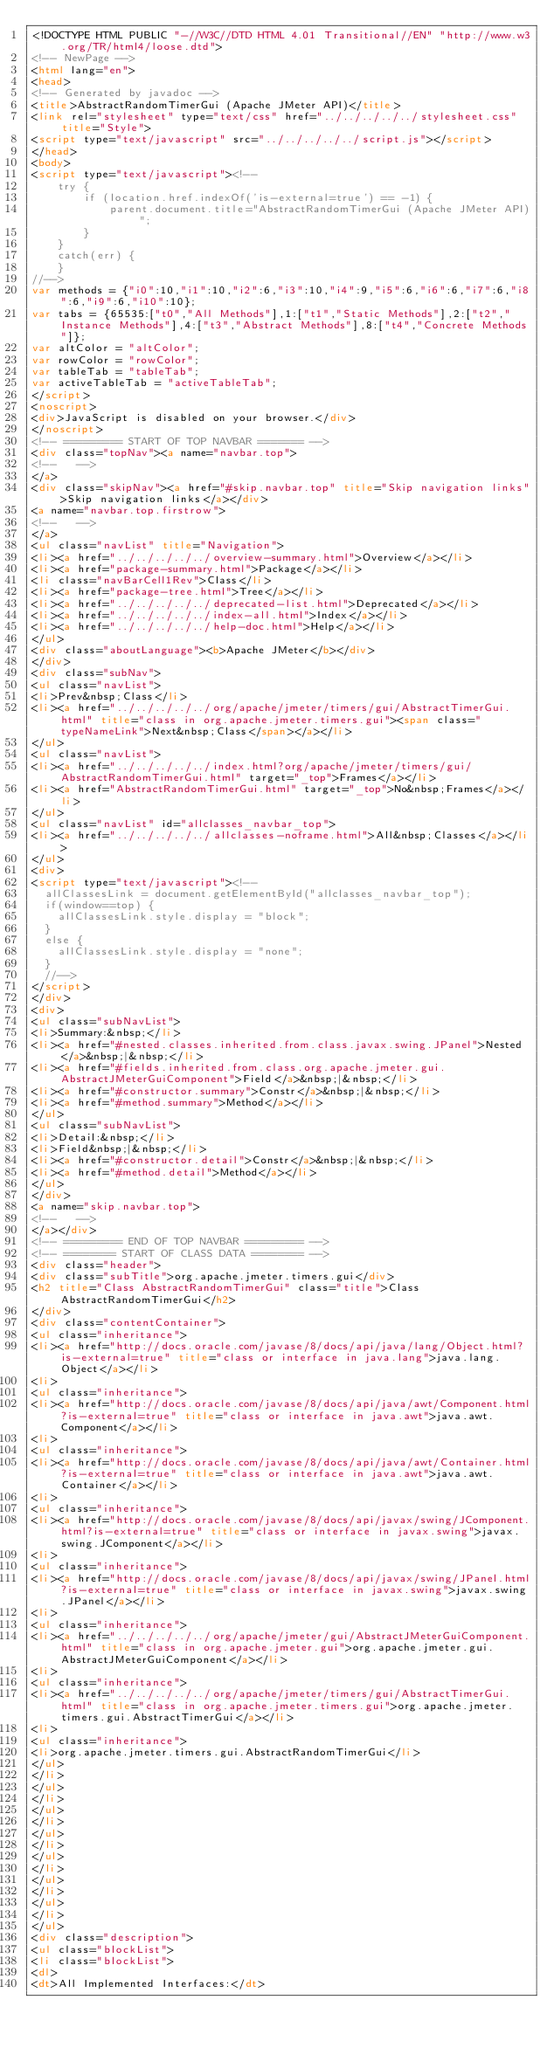<code> <loc_0><loc_0><loc_500><loc_500><_HTML_><!DOCTYPE HTML PUBLIC "-//W3C//DTD HTML 4.01 Transitional//EN" "http://www.w3.org/TR/html4/loose.dtd">
<!-- NewPage -->
<html lang="en">
<head>
<!-- Generated by javadoc -->
<title>AbstractRandomTimerGui (Apache JMeter API)</title>
<link rel="stylesheet" type="text/css" href="../../../../../stylesheet.css" title="Style">
<script type="text/javascript" src="../../../../../script.js"></script>
</head>
<body>
<script type="text/javascript"><!--
    try {
        if (location.href.indexOf('is-external=true') == -1) {
            parent.document.title="AbstractRandomTimerGui (Apache JMeter API)";
        }
    }
    catch(err) {
    }
//-->
var methods = {"i0":10,"i1":10,"i2":6,"i3":10,"i4":9,"i5":6,"i6":6,"i7":6,"i8":6,"i9":6,"i10":10};
var tabs = {65535:["t0","All Methods"],1:["t1","Static Methods"],2:["t2","Instance Methods"],4:["t3","Abstract Methods"],8:["t4","Concrete Methods"]};
var altColor = "altColor";
var rowColor = "rowColor";
var tableTab = "tableTab";
var activeTableTab = "activeTableTab";
</script>
<noscript>
<div>JavaScript is disabled on your browser.</div>
</noscript>
<!-- ========= START OF TOP NAVBAR ======= -->
<div class="topNav"><a name="navbar.top">
<!--   -->
</a>
<div class="skipNav"><a href="#skip.navbar.top" title="Skip navigation links">Skip navigation links</a></div>
<a name="navbar.top.firstrow">
<!--   -->
</a>
<ul class="navList" title="Navigation">
<li><a href="../../../../../overview-summary.html">Overview</a></li>
<li><a href="package-summary.html">Package</a></li>
<li class="navBarCell1Rev">Class</li>
<li><a href="package-tree.html">Tree</a></li>
<li><a href="../../../../../deprecated-list.html">Deprecated</a></li>
<li><a href="../../../../../index-all.html">Index</a></li>
<li><a href="../../../../../help-doc.html">Help</a></li>
</ul>
<div class="aboutLanguage"><b>Apache JMeter</b></div>
</div>
<div class="subNav">
<ul class="navList">
<li>Prev&nbsp;Class</li>
<li><a href="../../../../../org/apache/jmeter/timers/gui/AbstractTimerGui.html" title="class in org.apache.jmeter.timers.gui"><span class="typeNameLink">Next&nbsp;Class</span></a></li>
</ul>
<ul class="navList">
<li><a href="../../../../../index.html?org/apache/jmeter/timers/gui/AbstractRandomTimerGui.html" target="_top">Frames</a></li>
<li><a href="AbstractRandomTimerGui.html" target="_top">No&nbsp;Frames</a></li>
</ul>
<ul class="navList" id="allclasses_navbar_top">
<li><a href="../../../../../allclasses-noframe.html">All&nbsp;Classes</a></li>
</ul>
<div>
<script type="text/javascript"><!--
  allClassesLink = document.getElementById("allclasses_navbar_top");
  if(window==top) {
    allClassesLink.style.display = "block";
  }
  else {
    allClassesLink.style.display = "none";
  }
  //-->
</script>
</div>
<div>
<ul class="subNavList">
<li>Summary:&nbsp;</li>
<li><a href="#nested.classes.inherited.from.class.javax.swing.JPanel">Nested</a>&nbsp;|&nbsp;</li>
<li><a href="#fields.inherited.from.class.org.apache.jmeter.gui.AbstractJMeterGuiComponent">Field</a>&nbsp;|&nbsp;</li>
<li><a href="#constructor.summary">Constr</a>&nbsp;|&nbsp;</li>
<li><a href="#method.summary">Method</a></li>
</ul>
<ul class="subNavList">
<li>Detail:&nbsp;</li>
<li>Field&nbsp;|&nbsp;</li>
<li><a href="#constructor.detail">Constr</a>&nbsp;|&nbsp;</li>
<li><a href="#method.detail">Method</a></li>
</ul>
</div>
<a name="skip.navbar.top">
<!--   -->
</a></div>
<!-- ========= END OF TOP NAVBAR ========= -->
<!-- ======== START OF CLASS DATA ======== -->
<div class="header">
<div class="subTitle">org.apache.jmeter.timers.gui</div>
<h2 title="Class AbstractRandomTimerGui" class="title">Class AbstractRandomTimerGui</h2>
</div>
<div class="contentContainer">
<ul class="inheritance">
<li><a href="http://docs.oracle.com/javase/8/docs/api/java/lang/Object.html?is-external=true" title="class or interface in java.lang">java.lang.Object</a></li>
<li>
<ul class="inheritance">
<li><a href="http://docs.oracle.com/javase/8/docs/api/java/awt/Component.html?is-external=true" title="class or interface in java.awt">java.awt.Component</a></li>
<li>
<ul class="inheritance">
<li><a href="http://docs.oracle.com/javase/8/docs/api/java/awt/Container.html?is-external=true" title="class or interface in java.awt">java.awt.Container</a></li>
<li>
<ul class="inheritance">
<li><a href="http://docs.oracle.com/javase/8/docs/api/javax/swing/JComponent.html?is-external=true" title="class or interface in javax.swing">javax.swing.JComponent</a></li>
<li>
<ul class="inheritance">
<li><a href="http://docs.oracle.com/javase/8/docs/api/javax/swing/JPanel.html?is-external=true" title="class or interface in javax.swing">javax.swing.JPanel</a></li>
<li>
<ul class="inheritance">
<li><a href="../../../../../org/apache/jmeter/gui/AbstractJMeterGuiComponent.html" title="class in org.apache.jmeter.gui">org.apache.jmeter.gui.AbstractJMeterGuiComponent</a></li>
<li>
<ul class="inheritance">
<li><a href="../../../../../org/apache/jmeter/timers/gui/AbstractTimerGui.html" title="class in org.apache.jmeter.timers.gui">org.apache.jmeter.timers.gui.AbstractTimerGui</a></li>
<li>
<ul class="inheritance">
<li>org.apache.jmeter.timers.gui.AbstractRandomTimerGui</li>
</ul>
</li>
</ul>
</li>
</ul>
</li>
</ul>
</li>
</ul>
</li>
</ul>
</li>
</ul>
</li>
</ul>
<div class="description">
<ul class="blockList">
<li class="blockList">
<dl>
<dt>All Implemented Interfaces:</dt></code> 